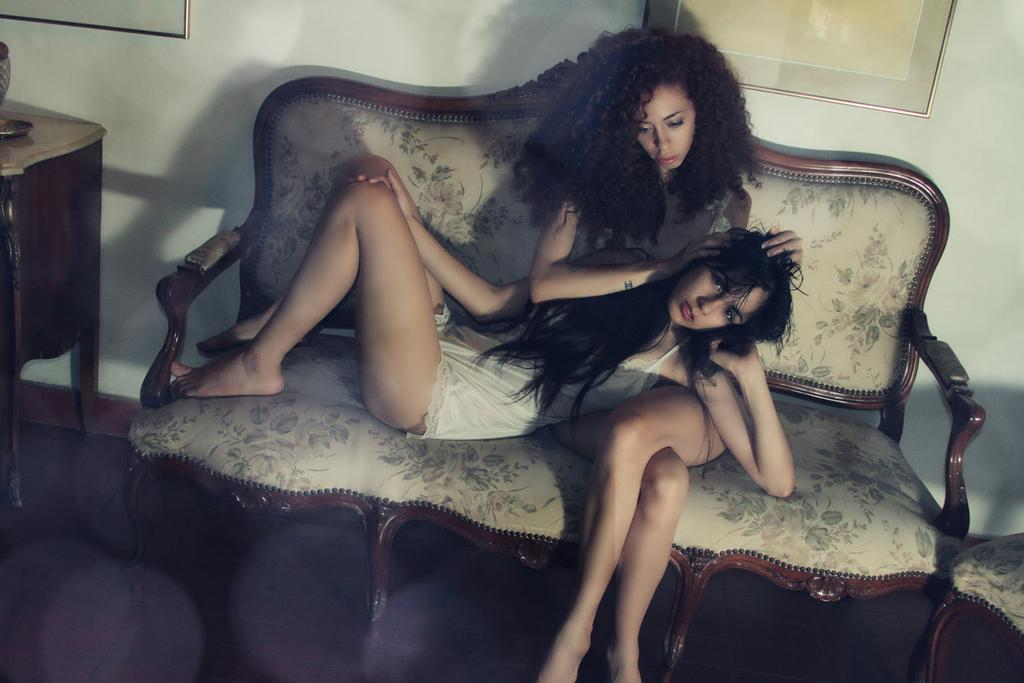What can be seen on the wall in the background of the image? There are frames on a wall in the background of the image. How many people are sitting on the sofa in the image? There are two women on a sofa in the image. What is located on the left side of the picture? There is a table on the left side of the picture. What is placed on the table in the image? There is an object on the table in the image. What type of protest is happening in the image? There is no protest present in the image; it features two women on a sofa and a table with an object on it. What message of peace is being conveyed in the image? There is no message of peace present in the image; it does not depict any such theme. 